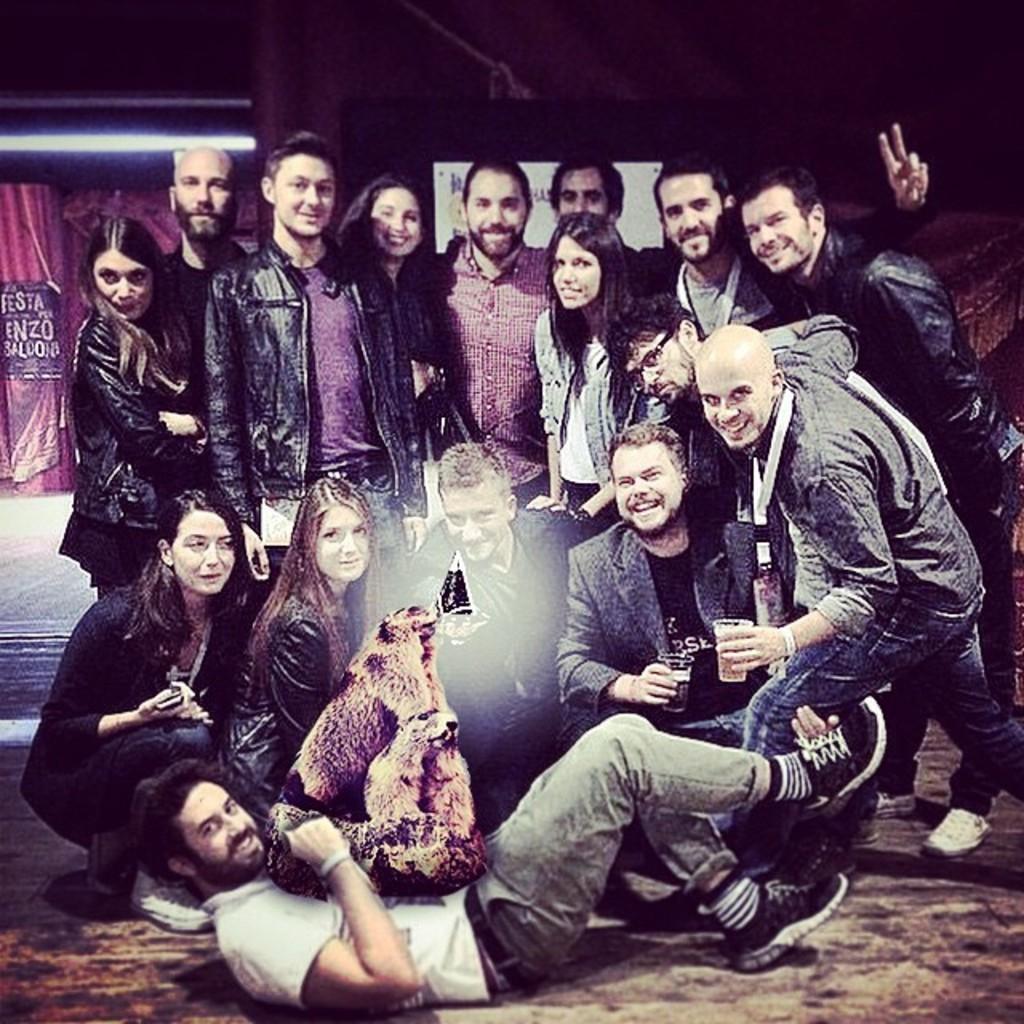How would you summarize this image in a sentence or two? This image is taken indoors. At the bottom of the image there is a floor and a man is lying on the floor and there is something on the man. In the background there is a wall with two boards with text on them and a light. In the middle of the image a few people are standing and a few are sitting. 